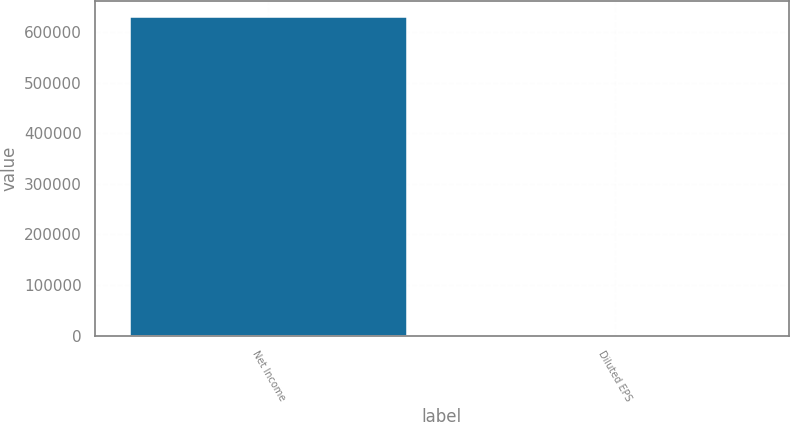<chart> <loc_0><loc_0><loc_500><loc_500><bar_chart><fcel>Net Income<fcel>Diluted EPS<nl><fcel>629320<fcel>1.98<nl></chart> 